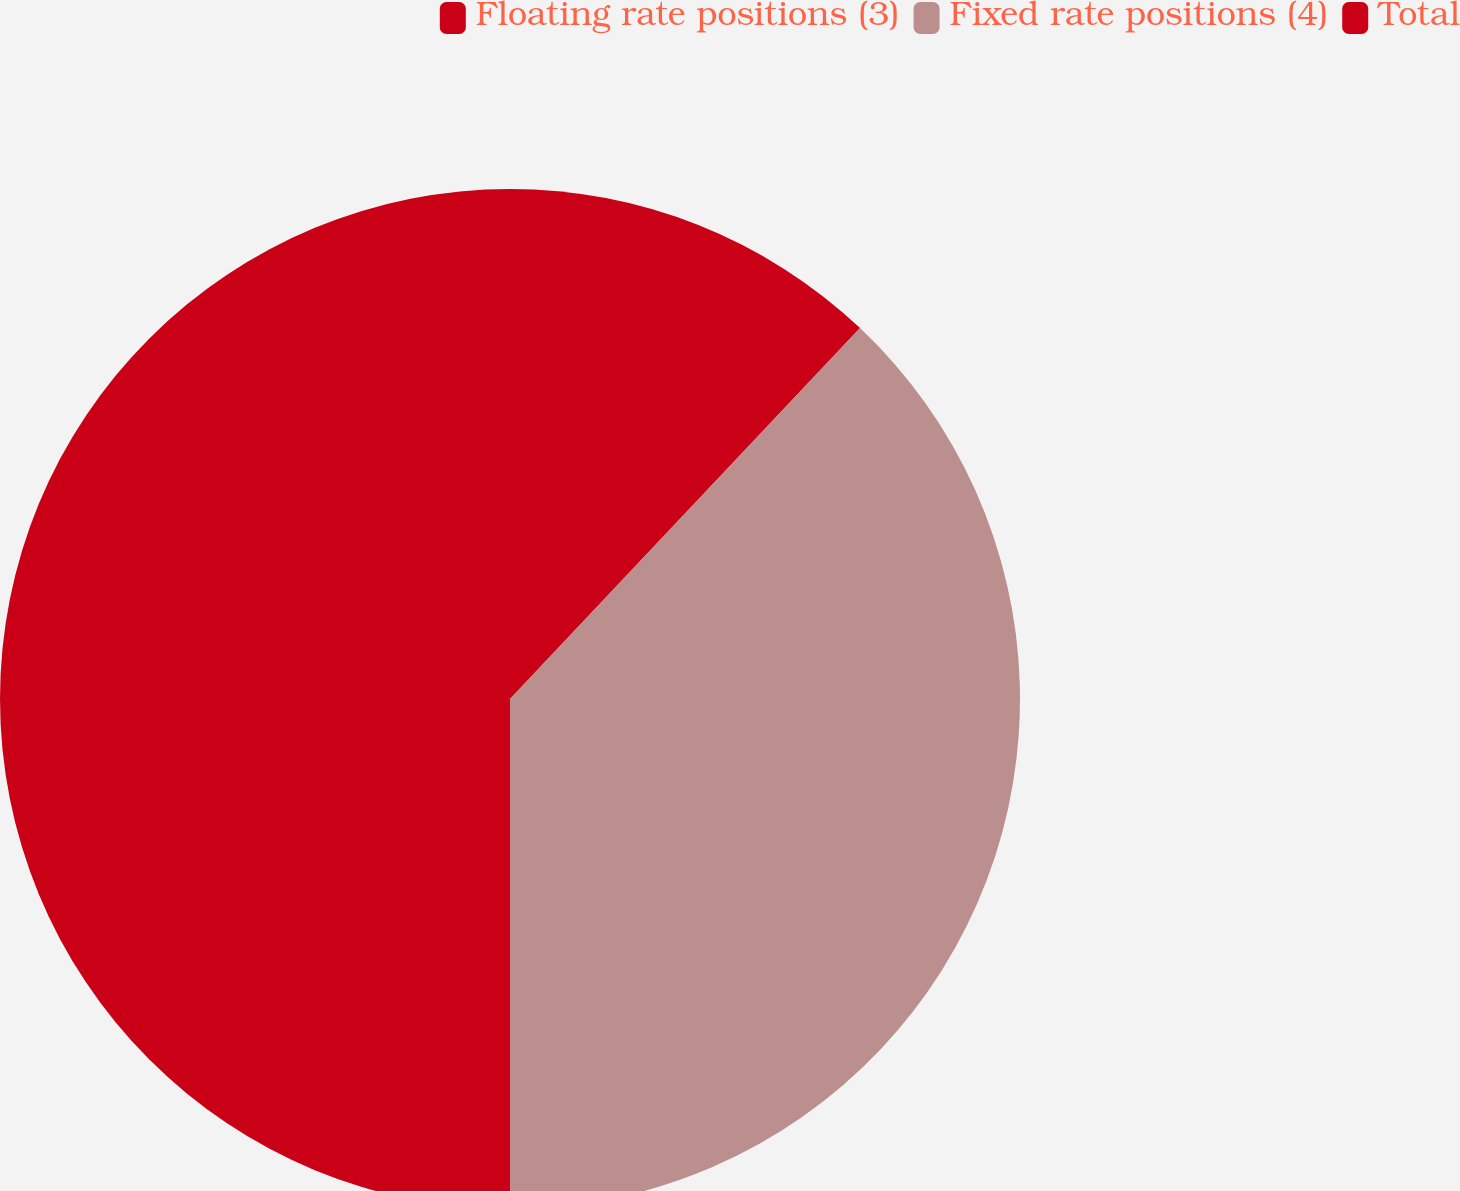<chart> <loc_0><loc_0><loc_500><loc_500><pie_chart><fcel>Floating rate positions (3)<fcel>Fixed rate positions (4)<fcel>Total<nl><fcel>12.04%<fcel>37.96%<fcel>50.0%<nl></chart> 